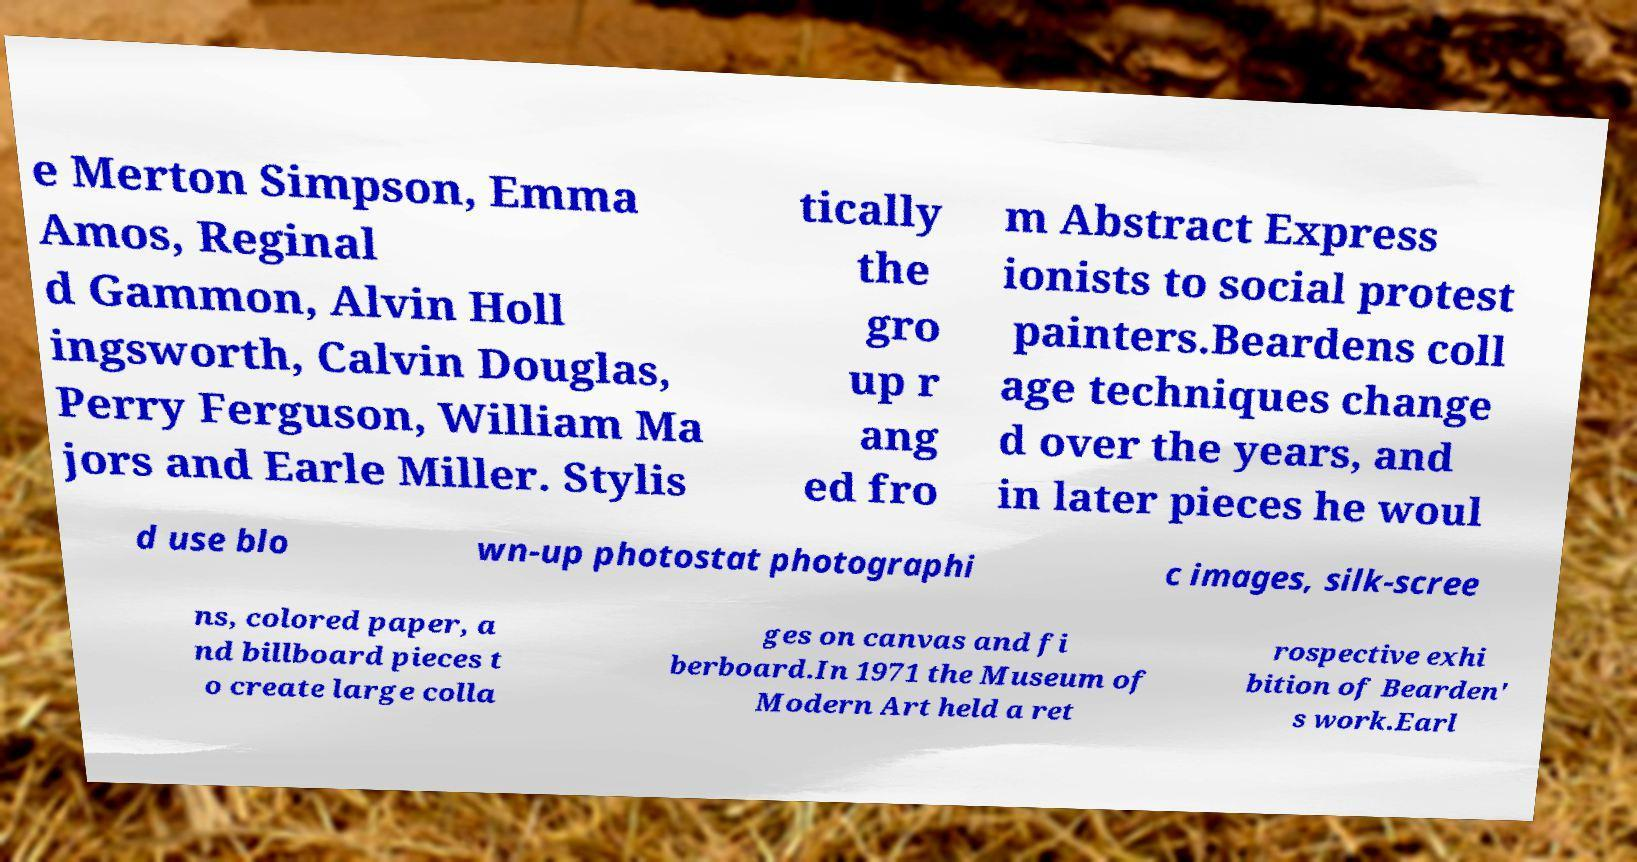I need the written content from this picture converted into text. Can you do that? e Merton Simpson, Emma Amos, Reginal d Gammon, Alvin Holl ingsworth, Calvin Douglas, Perry Ferguson, William Ma jors and Earle Miller. Stylis tically the gro up r ang ed fro m Abstract Express ionists to social protest painters.Beardens coll age techniques change d over the years, and in later pieces he woul d use blo wn-up photostat photographi c images, silk-scree ns, colored paper, a nd billboard pieces t o create large colla ges on canvas and fi berboard.In 1971 the Museum of Modern Art held a ret rospective exhi bition of Bearden' s work.Earl 